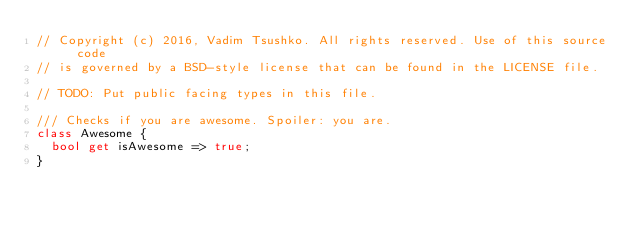Convert code to text. <code><loc_0><loc_0><loc_500><loc_500><_Dart_>// Copyright (c) 2016, Vadim Tsushko. All rights reserved. Use of this source code
// is governed by a BSD-style license that can be found in the LICENSE file.

// TODO: Put public facing types in this file.

/// Checks if you are awesome. Spoiler: you are.
class Awesome {
  bool get isAwesome => true;
}
</code> 